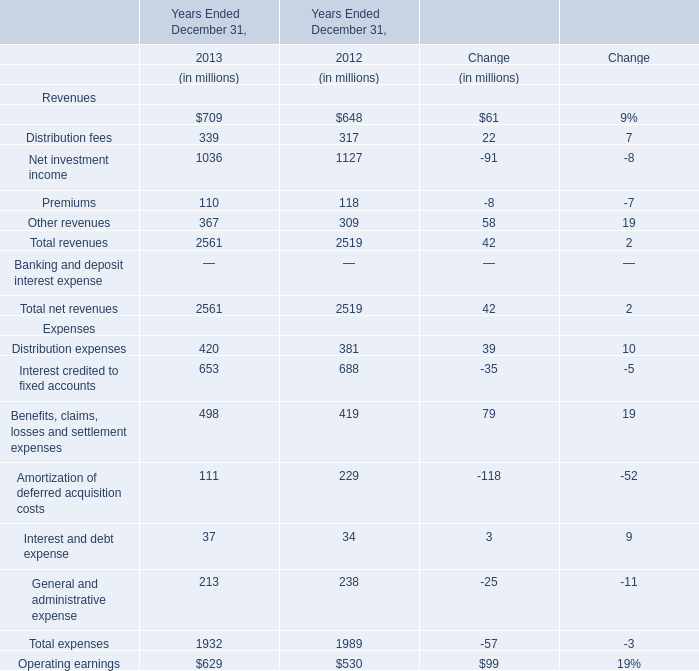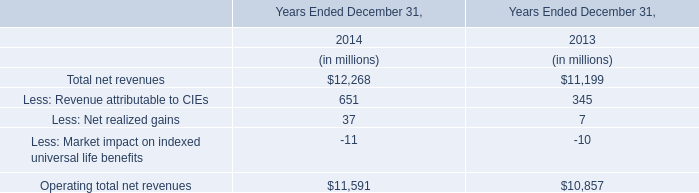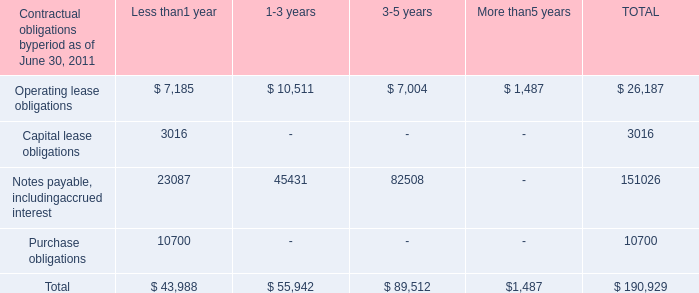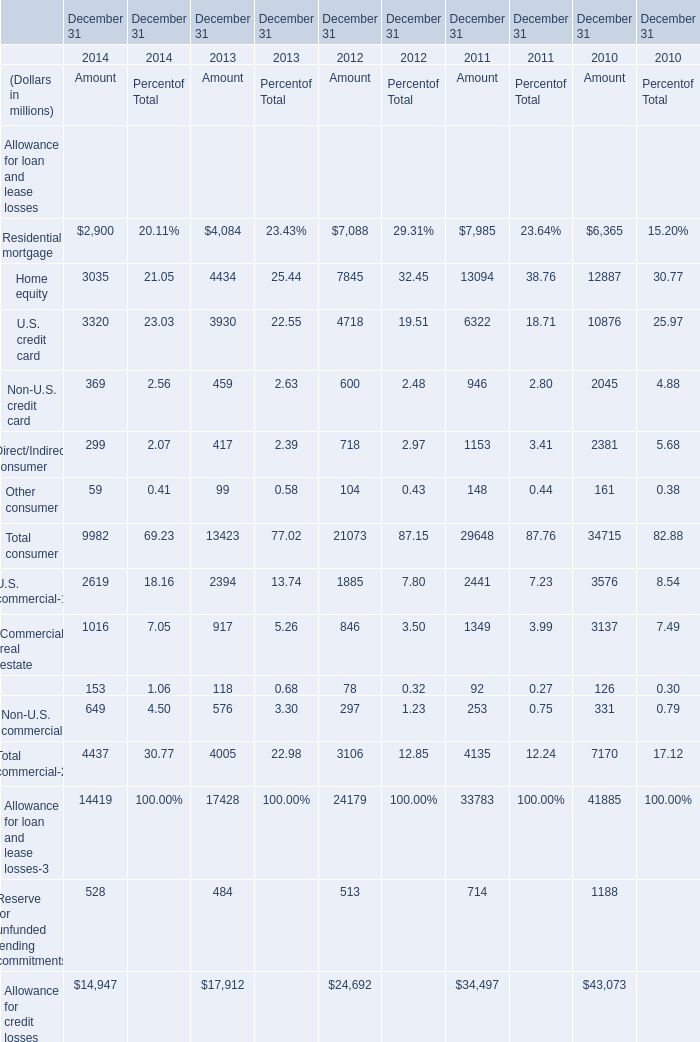What's the average of Purchase obligations of Less than1 year, and Allowance for credit losses of December 31 2010 Amount ? 
Computations: ((10700.0 + 43073.0) / 2)
Answer: 26886.5. 